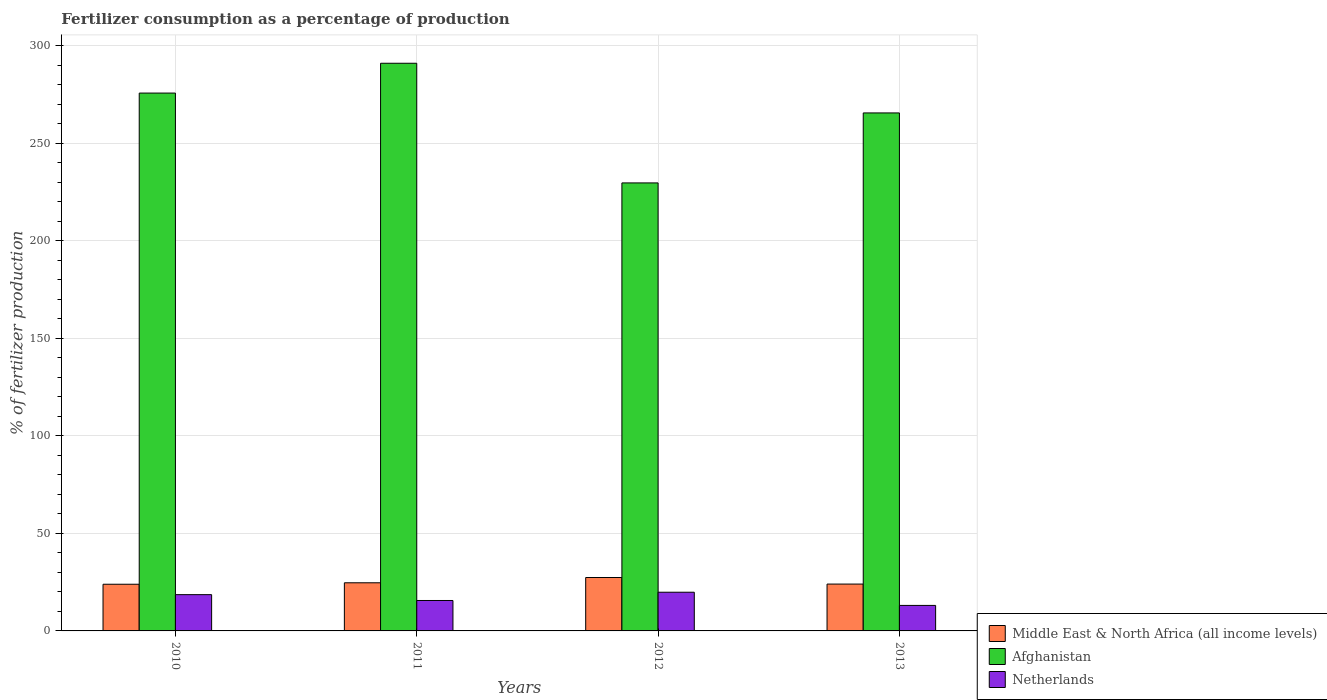How many groups of bars are there?
Offer a terse response. 4. How many bars are there on the 3rd tick from the right?
Offer a very short reply. 3. What is the label of the 4th group of bars from the left?
Make the answer very short. 2013. What is the percentage of fertilizers consumed in Netherlands in 2012?
Ensure brevity in your answer.  19.84. Across all years, what is the maximum percentage of fertilizers consumed in Middle East & North Africa (all income levels)?
Offer a very short reply. 27.39. Across all years, what is the minimum percentage of fertilizers consumed in Middle East & North Africa (all income levels)?
Give a very brief answer. 23.94. In which year was the percentage of fertilizers consumed in Afghanistan maximum?
Your answer should be compact. 2011. In which year was the percentage of fertilizers consumed in Afghanistan minimum?
Provide a succinct answer. 2012. What is the total percentage of fertilizers consumed in Middle East & North Africa (all income levels) in the graph?
Provide a succinct answer. 100.03. What is the difference between the percentage of fertilizers consumed in Afghanistan in 2010 and that in 2011?
Offer a terse response. -15.29. What is the difference between the percentage of fertilizers consumed in Netherlands in 2011 and the percentage of fertilizers consumed in Middle East & North Africa (all income levels) in 2010?
Your answer should be very brief. -8.33. What is the average percentage of fertilizers consumed in Afghanistan per year?
Give a very brief answer. 265.58. In the year 2013, what is the difference between the percentage of fertilizers consumed in Afghanistan and percentage of fertilizers consumed in Middle East & North Africa (all income levels)?
Provide a succinct answer. 241.61. What is the ratio of the percentage of fertilizers consumed in Afghanistan in 2011 to that in 2012?
Give a very brief answer. 1.27. Is the difference between the percentage of fertilizers consumed in Afghanistan in 2012 and 2013 greater than the difference between the percentage of fertilizers consumed in Middle East & North Africa (all income levels) in 2012 and 2013?
Offer a terse response. No. What is the difference between the highest and the second highest percentage of fertilizers consumed in Netherlands?
Offer a terse response. 1.24. What is the difference between the highest and the lowest percentage of fertilizers consumed in Netherlands?
Provide a succinct answer. 6.76. In how many years, is the percentage of fertilizers consumed in Afghanistan greater than the average percentage of fertilizers consumed in Afghanistan taken over all years?
Your answer should be very brief. 3. How many bars are there?
Offer a very short reply. 12. How many years are there in the graph?
Your response must be concise. 4. Are the values on the major ticks of Y-axis written in scientific E-notation?
Provide a short and direct response. No. Does the graph contain any zero values?
Your answer should be very brief. No. How many legend labels are there?
Keep it short and to the point. 3. How are the legend labels stacked?
Your answer should be compact. Vertical. What is the title of the graph?
Offer a terse response. Fertilizer consumption as a percentage of production. What is the label or title of the X-axis?
Provide a short and direct response. Years. What is the label or title of the Y-axis?
Your answer should be very brief. % of fertilizer production. What is the % of fertilizer production of Middle East & North Africa (all income levels) in 2010?
Provide a succinct answer. 23.94. What is the % of fertilizer production of Afghanistan in 2010?
Your answer should be very brief. 275.82. What is the % of fertilizer production in Netherlands in 2010?
Make the answer very short. 18.6. What is the % of fertilizer production in Middle East & North Africa (all income levels) in 2011?
Give a very brief answer. 24.68. What is the % of fertilizer production of Afghanistan in 2011?
Ensure brevity in your answer.  291.11. What is the % of fertilizer production in Netherlands in 2011?
Offer a very short reply. 15.6. What is the % of fertilizer production in Middle East & North Africa (all income levels) in 2012?
Your answer should be compact. 27.39. What is the % of fertilizer production in Afghanistan in 2012?
Provide a succinct answer. 229.74. What is the % of fertilizer production of Netherlands in 2012?
Give a very brief answer. 19.84. What is the % of fertilizer production in Middle East & North Africa (all income levels) in 2013?
Your answer should be very brief. 24.02. What is the % of fertilizer production of Afghanistan in 2013?
Keep it short and to the point. 265.63. What is the % of fertilizer production in Netherlands in 2013?
Keep it short and to the point. 13.08. Across all years, what is the maximum % of fertilizer production of Middle East & North Africa (all income levels)?
Ensure brevity in your answer.  27.39. Across all years, what is the maximum % of fertilizer production in Afghanistan?
Give a very brief answer. 291.11. Across all years, what is the maximum % of fertilizer production of Netherlands?
Ensure brevity in your answer.  19.84. Across all years, what is the minimum % of fertilizer production in Middle East & North Africa (all income levels)?
Your answer should be compact. 23.94. Across all years, what is the minimum % of fertilizer production of Afghanistan?
Your answer should be very brief. 229.74. Across all years, what is the minimum % of fertilizer production in Netherlands?
Offer a very short reply. 13.08. What is the total % of fertilizer production of Middle East & North Africa (all income levels) in the graph?
Give a very brief answer. 100.03. What is the total % of fertilizer production of Afghanistan in the graph?
Offer a terse response. 1062.3. What is the total % of fertilizer production of Netherlands in the graph?
Offer a very short reply. 67.13. What is the difference between the % of fertilizer production of Middle East & North Africa (all income levels) in 2010 and that in 2011?
Your answer should be compact. -0.75. What is the difference between the % of fertilizer production of Afghanistan in 2010 and that in 2011?
Your response must be concise. -15.29. What is the difference between the % of fertilizer production of Netherlands in 2010 and that in 2011?
Offer a terse response. 3. What is the difference between the % of fertilizer production in Middle East & North Africa (all income levels) in 2010 and that in 2012?
Offer a very short reply. -3.45. What is the difference between the % of fertilizer production of Afghanistan in 2010 and that in 2012?
Provide a short and direct response. 46.07. What is the difference between the % of fertilizer production of Netherlands in 2010 and that in 2012?
Your response must be concise. -1.24. What is the difference between the % of fertilizer production of Middle East & North Africa (all income levels) in 2010 and that in 2013?
Offer a terse response. -0.08. What is the difference between the % of fertilizer production in Afghanistan in 2010 and that in 2013?
Provide a short and direct response. 10.18. What is the difference between the % of fertilizer production of Netherlands in 2010 and that in 2013?
Your response must be concise. 5.52. What is the difference between the % of fertilizer production in Middle East & North Africa (all income levels) in 2011 and that in 2012?
Make the answer very short. -2.7. What is the difference between the % of fertilizer production in Afghanistan in 2011 and that in 2012?
Ensure brevity in your answer.  61.36. What is the difference between the % of fertilizer production in Netherlands in 2011 and that in 2012?
Offer a terse response. -4.24. What is the difference between the % of fertilizer production of Middle East & North Africa (all income levels) in 2011 and that in 2013?
Provide a succinct answer. 0.66. What is the difference between the % of fertilizer production of Afghanistan in 2011 and that in 2013?
Your answer should be compact. 25.47. What is the difference between the % of fertilizer production of Netherlands in 2011 and that in 2013?
Give a very brief answer. 2.52. What is the difference between the % of fertilizer production in Middle East & North Africa (all income levels) in 2012 and that in 2013?
Provide a short and direct response. 3.37. What is the difference between the % of fertilizer production of Afghanistan in 2012 and that in 2013?
Offer a very short reply. -35.89. What is the difference between the % of fertilizer production of Netherlands in 2012 and that in 2013?
Provide a short and direct response. 6.76. What is the difference between the % of fertilizer production in Middle East & North Africa (all income levels) in 2010 and the % of fertilizer production in Afghanistan in 2011?
Your answer should be compact. -267.17. What is the difference between the % of fertilizer production of Middle East & North Africa (all income levels) in 2010 and the % of fertilizer production of Netherlands in 2011?
Offer a terse response. 8.33. What is the difference between the % of fertilizer production of Afghanistan in 2010 and the % of fertilizer production of Netherlands in 2011?
Ensure brevity in your answer.  260.21. What is the difference between the % of fertilizer production of Middle East & North Africa (all income levels) in 2010 and the % of fertilizer production of Afghanistan in 2012?
Give a very brief answer. -205.81. What is the difference between the % of fertilizer production in Middle East & North Africa (all income levels) in 2010 and the % of fertilizer production in Netherlands in 2012?
Make the answer very short. 4.09. What is the difference between the % of fertilizer production of Afghanistan in 2010 and the % of fertilizer production of Netherlands in 2012?
Your response must be concise. 255.98. What is the difference between the % of fertilizer production of Middle East & North Africa (all income levels) in 2010 and the % of fertilizer production of Afghanistan in 2013?
Your answer should be compact. -241.7. What is the difference between the % of fertilizer production in Middle East & North Africa (all income levels) in 2010 and the % of fertilizer production in Netherlands in 2013?
Your response must be concise. 10.86. What is the difference between the % of fertilizer production of Afghanistan in 2010 and the % of fertilizer production of Netherlands in 2013?
Your answer should be very brief. 262.74. What is the difference between the % of fertilizer production in Middle East & North Africa (all income levels) in 2011 and the % of fertilizer production in Afghanistan in 2012?
Offer a terse response. -205.06. What is the difference between the % of fertilizer production in Middle East & North Africa (all income levels) in 2011 and the % of fertilizer production in Netherlands in 2012?
Keep it short and to the point. 4.84. What is the difference between the % of fertilizer production in Afghanistan in 2011 and the % of fertilizer production in Netherlands in 2012?
Make the answer very short. 271.26. What is the difference between the % of fertilizer production of Middle East & North Africa (all income levels) in 2011 and the % of fertilizer production of Afghanistan in 2013?
Offer a very short reply. -240.95. What is the difference between the % of fertilizer production in Middle East & North Africa (all income levels) in 2011 and the % of fertilizer production in Netherlands in 2013?
Ensure brevity in your answer.  11.6. What is the difference between the % of fertilizer production in Afghanistan in 2011 and the % of fertilizer production in Netherlands in 2013?
Give a very brief answer. 278.02. What is the difference between the % of fertilizer production in Middle East & North Africa (all income levels) in 2012 and the % of fertilizer production in Afghanistan in 2013?
Keep it short and to the point. -238.25. What is the difference between the % of fertilizer production of Middle East & North Africa (all income levels) in 2012 and the % of fertilizer production of Netherlands in 2013?
Make the answer very short. 14.31. What is the difference between the % of fertilizer production in Afghanistan in 2012 and the % of fertilizer production in Netherlands in 2013?
Give a very brief answer. 216.66. What is the average % of fertilizer production in Middle East & North Africa (all income levels) per year?
Make the answer very short. 25.01. What is the average % of fertilizer production in Afghanistan per year?
Give a very brief answer. 265.58. What is the average % of fertilizer production in Netherlands per year?
Ensure brevity in your answer.  16.78. In the year 2010, what is the difference between the % of fertilizer production of Middle East & North Africa (all income levels) and % of fertilizer production of Afghanistan?
Provide a succinct answer. -251.88. In the year 2010, what is the difference between the % of fertilizer production of Middle East & North Africa (all income levels) and % of fertilizer production of Netherlands?
Keep it short and to the point. 5.34. In the year 2010, what is the difference between the % of fertilizer production of Afghanistan and % of fertilizer production of Netherlands?
Provide a short and direct response. 257.22. In the year 2011, what is the difference between the % of fertilizer production of Middle East & North Africa (all income levels) and % of fertilizer production of Afghanistan?
Keep it short and to the point. -266.42. In the year 2011, what is the difference between the % of fertilizer production of Middle East & North Africa (all income levels) and % of fertilizer production of Netherlands?
Make the answer very short. 9.08. In the year 2011, what is the difference between the % of fertilizer production in Afghanistan and % of fertilizer production in Netherlands?
Make the answer very short. 275.5. In the year 2012, what is the difference between the % of fertilizer production in Middle East & North Africa (all income levels) and % of fertilizer production in Afghanistan?
Offer a very short reply. -202.36. In the year 2012, what is the difference between the % of fertilizer production in Middle East & North Africa (all income levels) and % of fertilizer production in Netherlands?
Provide a short and direct response. 7.54. In the year 2012, what is the difference between the % of fertilizer production of Afghanistan and % of fertilizer production of Netherlands?
Your response must be concise. 209.9. In the year 2013, what is the difference between the % of fertilizer production of Middle East & North Africa (all income levels) and % of fertilizer production of Afghanistan?
Your response must be concise. -241.61. In the year 2013, what is the difference between the % of fertilizer production of Middle East & North Africa (all income levels) and % of fertilizer production of Netherlands?
Provide a succinct answer. 10.94. In the year 2013, what is the difference between the % of fertilizer production in Afghanistan and % of fertilizer production in Netherlands?
Your answer should be compact. 252.55. What is the ratio of the % of fertilizer production of Middle East & North Africa (all income levels) in 2010 to that in 2011?
Offer a very short reply. 0.97. What is the ratio of the % of fertilizer production in Afghanistan in 2010 to that in 2011?
Your answer should be very brief. 0.95. What is the ratio of the % of fertilizer production of Netherlands in 2010 to that in 2011?
Your response must be concise. 1.19. What is the ratio of the % of fertilizer production of Middle East & North Africa (all income levels) in 2010 to that in 2012?
Ensure brevity in your answer.  0.87. What is the ratio of the % of fertilizer production of Afghanistan in 2010 to that in 2012?
Provide a short and direct response. 1.2. What is the ratio of the % of fertilizer production in Middle East & North Africa (all income levels) in 2010 to that in 2013?
Offer a terse response. 1. What is the ratio of the % of fertilizer production in Afghanistan in 2010 to that in 2013?
Your response must be concise. 1.04. What is the ratio of the % of fertilizer production in Netherlands in 2010 to that in 2013?
Keep it short and to the point. 1.42. What is the ratio of the % of fertilizer production in Middle East & North Africa (all income levels) in 2011 to that in 2012?
Your response must be concise. 0.9. What is the ratio of the % of fertilizer production in Afghanistan in 2011 to that in 2012?
Provide a succinct answer. 1.27. What is the ratio of the % of fertilizer production in Netherlands in 2011 to that in 2012?
Offer a very short reply. 0.79. What is the ratio of the % of fertilizer production in Middle East & North Africa (all income levels) in 2011 to that in 2013?
Your response must be concise. 1.03. What is the ratio of the % of fertilizer production of Afghanistan in 2011 to that in 2013?
Offer a terse response. 1.1. What is the ratio of the % of fertilizer production in Netherlands in 2011 to that in 2013?
Your answer should be compact. 1.19. What is the ratio of the % of fertilizer production of Middle East & North Africa (all income levels) in 2012 to that in 2013?
Provide a succinct answer. 1.14. What is the ratio of the % of fertilizer production in Afghanistan in 2012 to that in 2013?
Give a very brief answer. 0.86. What is the ratio of the % of fertilizer production in Netherlands in 2012 to that in 2013?
Give a very brief answer. 1.52. What is the difference between the highest and the second highest % of fertilizer production in Middle East & North Africa (all income levels)?
Provide a succinct answer. 2.7. What is the difference between the highest and the second highest % of fertilizer production in Afghanistan?
Your answer should be compact. 15.29. What is the difference between the highest and the second highest % of fertilizer production in Netherlands?
Your response must be concise. 1.24. What is the difference between the highest and the lowest % of fertilizer production of Middle East & North Africa (all income levels)?
Keep it short and to the point. 3.45. What is the difference between the highest and the lowest % of fertilizer production of Afghanistan?
Offer a very short reply. 61.36. What is the difference between the highest and the lowest % of fertilizer production in Netherlands?
Offer a very short reply. 6.76. 